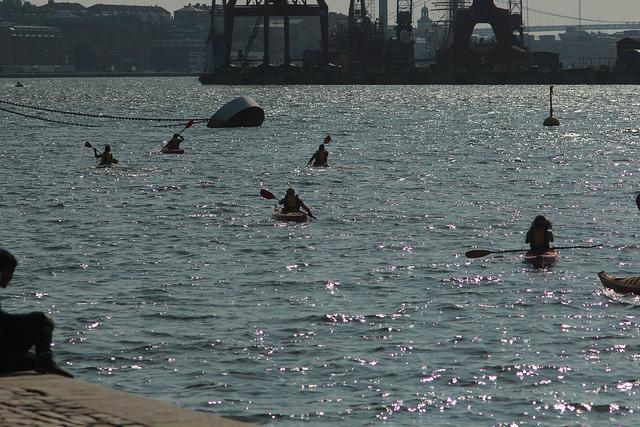Yes there are?
Give a very brief answer. No. How many people are kayaking?
Concise answer only. 5. What man made structure can you see in the distance?
Be succinct. Bridge. What sport is the man participating in?
Write a very short answer. Kayaking. Is there a person sitting on the embankment?
Be succinct. Yes. 